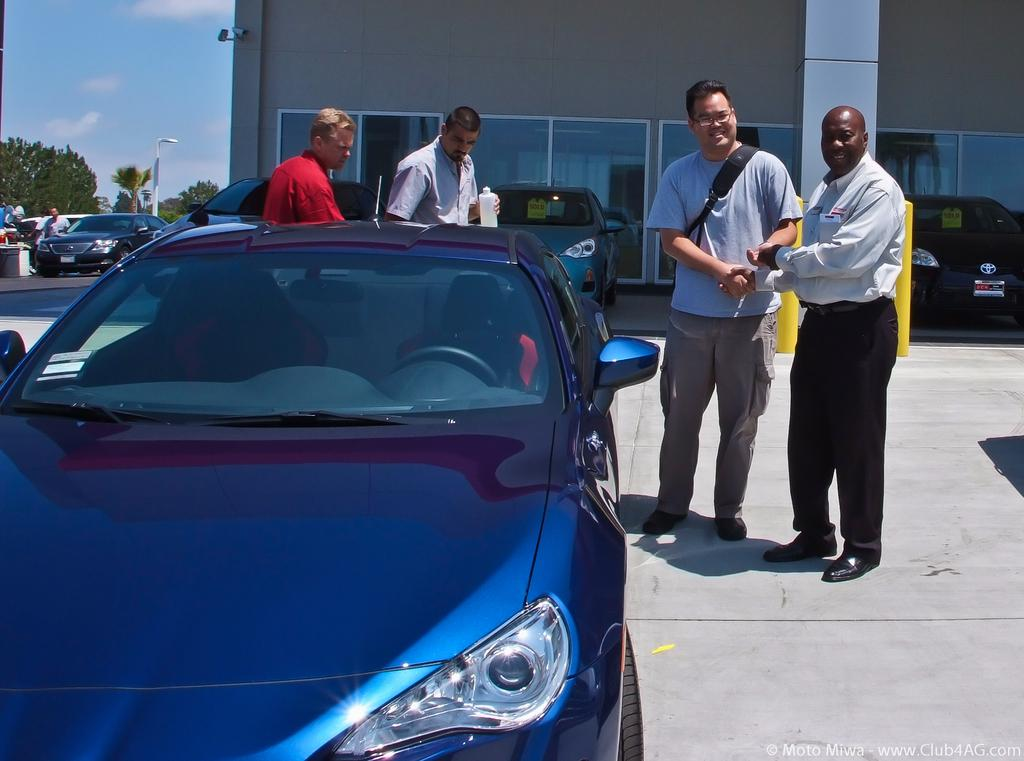What can be seen in the image involving people? There are people standing in the image. What type of vehicles are parked in the image? Cars are parked in the image. What type of structure is present in the image? There is a building in the image. What can be seen in the left background of the image? Trees and a street light are visible in the left background of the image. What part of the natural environment is visible in the image? The sky is visible in the image. Can you tell me how many times the son has pulled the car in the image? There is no mention of a son or a car being pulled in the image. What type of fruit is being crushed by the people in the image? There is no fruit or crushing activity depicted in the image. 